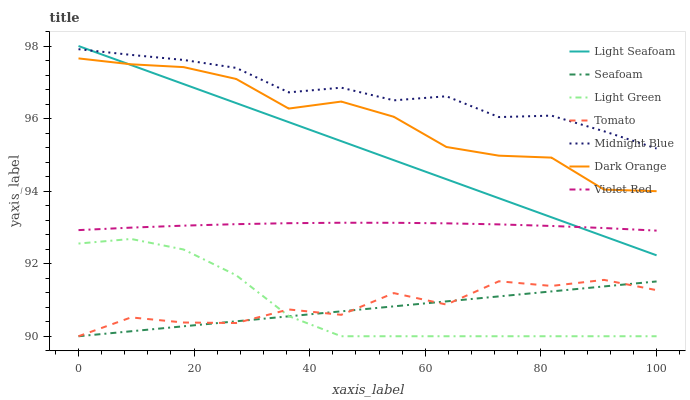Does Seafoam have the minimum area under the curve?
Answer yes or no. Yes. Does Midnight Blue have the maximum area under the curve?
Answer yes or no. Yes. Does Dark Orange have the minimum area under the curve?
Answer yes or no. No. Does Dark Orange have the maximum area under the curve?
Answer yes or no. No. Is Seafoam the smoothest?
Answer yes or no. Yes. Is Tomato the roughest?
Answer yes or no. Yes. Is Dark Orange the smoothest?
Answer yes or no. No. Is Dark Orange the roughest?
Answer yes or no. No. Does Tomato have the lowest value?
Answer yes or no. Yes. Does Dark Orange have the lowest value?
Answer yes or no. No. Does Light Seafoam have the highest value?
Answer yes or no. Yes. Does Dark Orange have the highest value?
Answer yes or no. No. Is Tomato less than Light Seafoam?
Answer yes or no. Yes. Is Dark Orange greater than Tomato?
Answer yes or no. Yes. Does Tomato intersect Seafoam?
Answer yes or no. Yes. Is Tomato less than Seafoam?
Answer yes or no. No. Is Tomato greater than Seafoam?
Answer yes or no. No. Does Tomato intersect Light Seafoam?
Answer yes or no. No. 